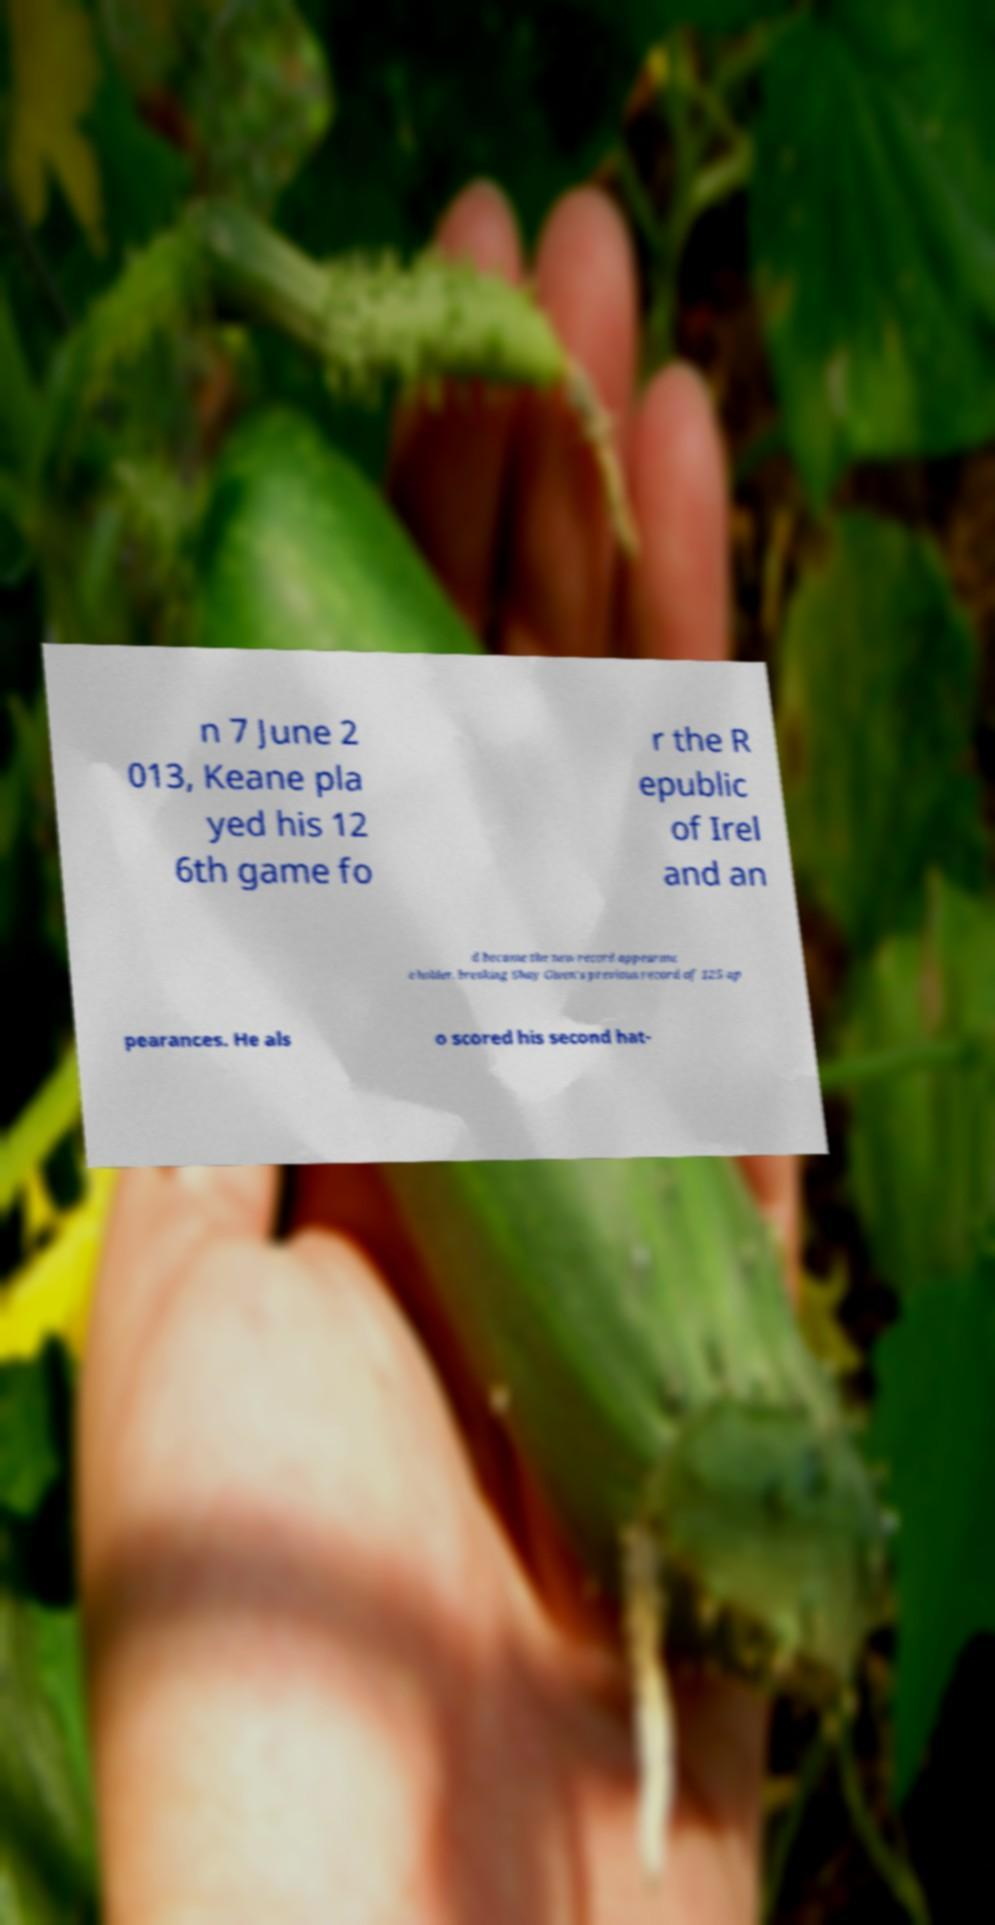Can you read and provide the text displayed in the image?This photo seems to have some interesting text. Can you extract and type it out for me? n 7 June 2 013, Keane pla yed his 12 6th game fo r the R epublic of Irel and an d became the new record appearanc e holder, breaking Shay Given's previous record of 125 ap pearances. He als o scored his second hat- 